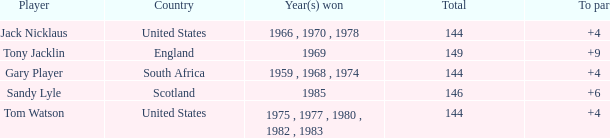What player had a To par smaller than 9 and won in 1985? Sandy Lyle. 